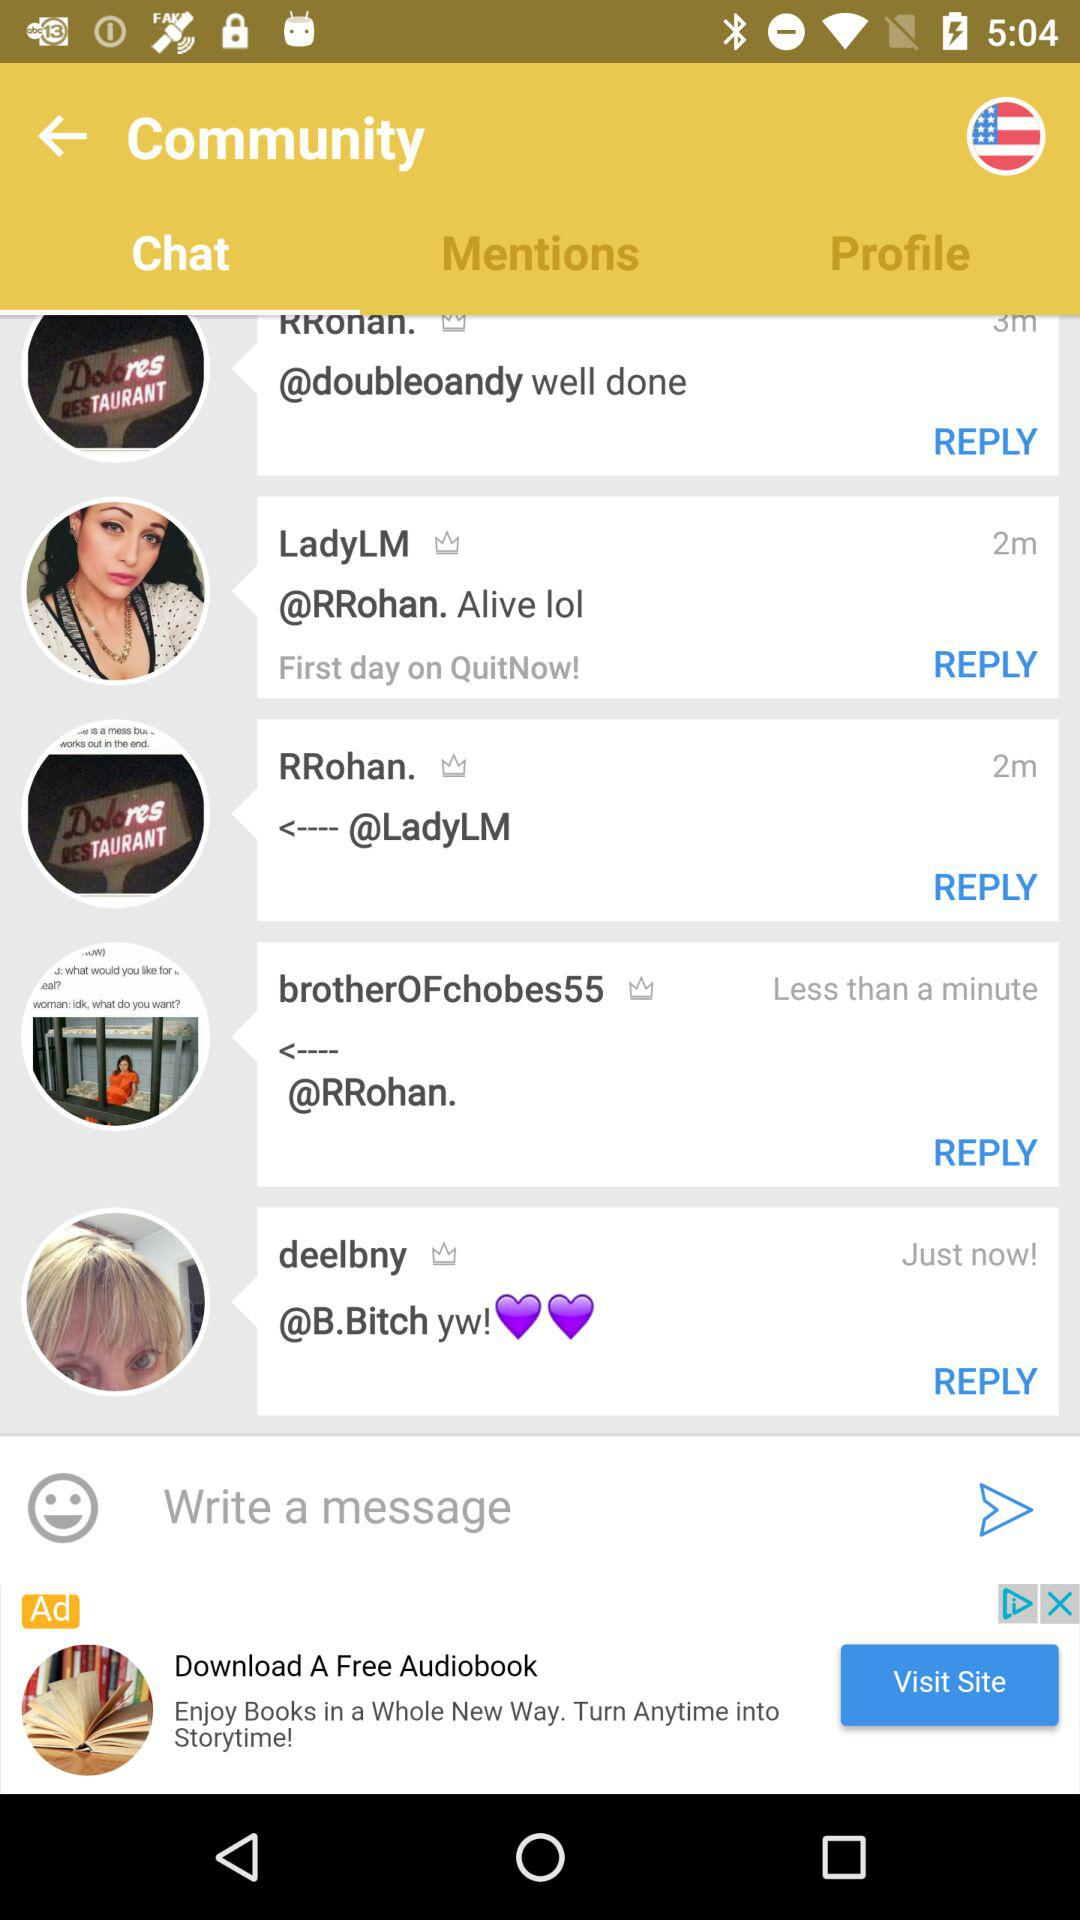What are the available usernames in "Chat"? The available usernames are "LadyLM", "RRohan.", "brotherOFchobes55", "deelbny" and "B.Bitch". 